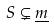Convert formula to latex. <formula><loc_0><loc_0><loc_500><loc_500>S \subsetneq \underline { m }</formula> 